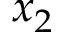<formula> <loc_0><loc_0><loc_500><loc_500>x _ { 2 }</formula> 